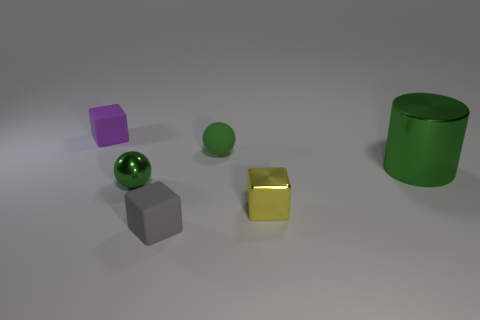Is the color of the large metallic cylinder the same as the tiny metallic ball?
Your answer should be very brief. Yes. Is the number of gray rubber things in front of the green cylinder less than the number of small balls that are on the left side of the gray rubber block?
Your response must be concise. No. What is the color of the other rubber object that is the same shape as the small purple rubber object?
Offer a terse response. Gray. There is a green thing that is in front of the metallic cylinder; is it the same size as the tiny purple rubber block?
Keep it short and to the point. Yes. Are there fewer tiny rubber objects on the right side of the tiny purple rubber object than gray matte cubes?
Your answer should be compact. No. Are there any other things that have the same size as the green shiny cylinder?
Offer a very short reply. No. There is a green metal thing on the right side of the small green object to the left of the tiny gray rubber object; how big is it?
Give a very brief answer. Large. Is there anything else that is the same shape as the big object?
Make the answer very short. No. Are there fewer small green spheres than things?
Ensure brevity in your answer.  Yes. There is a block that is in front of the matte ball and on the left side of the yellow object; what is it made of?
Keep it short and to the point. Rubber. 